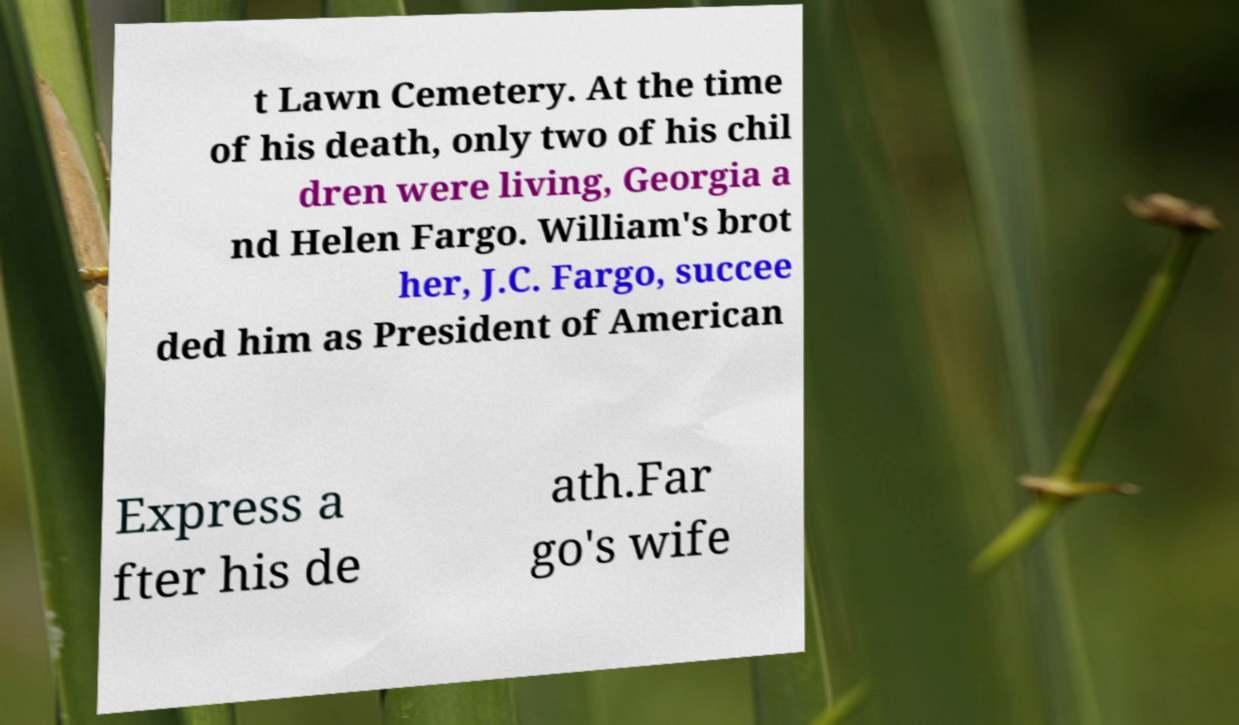I need the written content from this picture converted into text. Can you do that? t Lawn Cemetery. At the time of his death, only two of his chil dren were living, Georgia a nd Helen Fargo. William's brot her, J.C. Fargo, succee ded him as President of American Express a fter his de ath.Far go's wife 